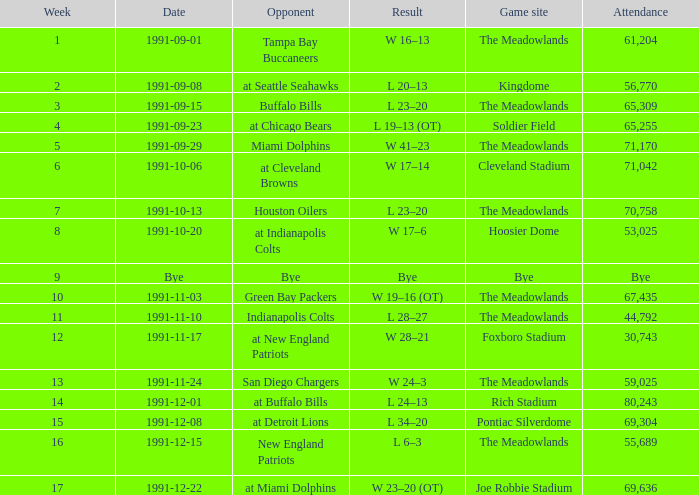What was the Result of the Game at the Meadowlands on 1991-09-01? W 16–13. 